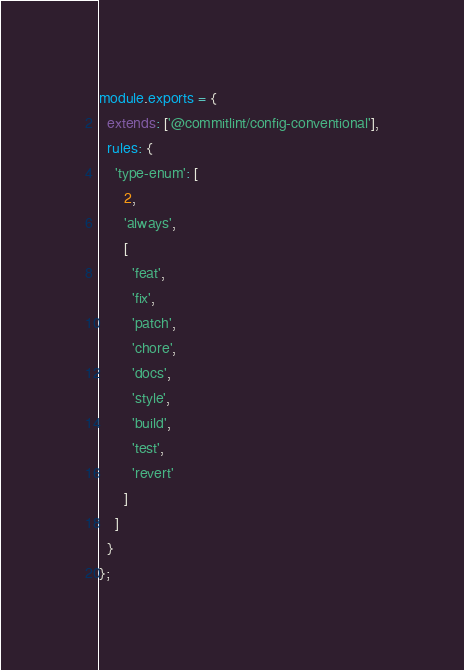Convert code to text. <code><loc_0><loc_0><loc_500><loc_500><_JavaScript_>module.exports = {
  extends: ['@commitlint/config-conventional'],
  rules: {
    'type-enum': [
      2,
      'always',
      [
        'feat',
        'fix',
        'patch',
        'chore',
        'docs',
        'style',
        'build',
        'test',
        'revert'
      ]
    ]
  }
};
</code> 